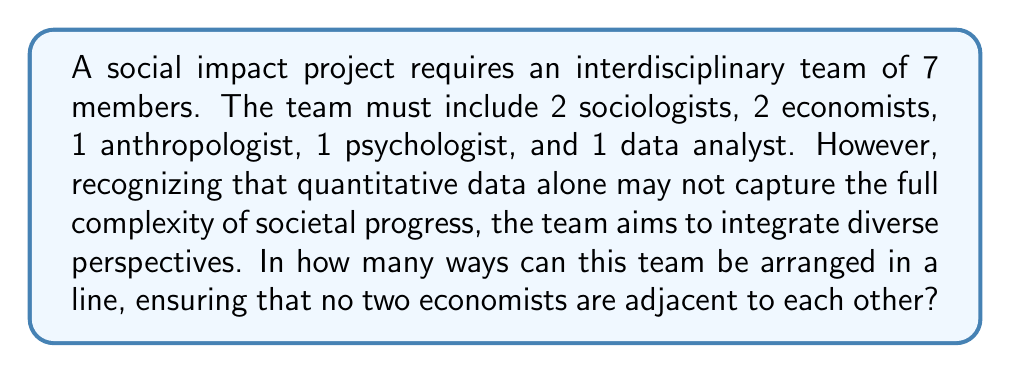Give your solution to this math problem. Let's approach this step-by-step:

1) First, consider the total number of team members: 7

2) We need to ensure that no two economists are adjacent. One way to achieve this is to first arrange all other members and then insert the economists into the gaps.

3) Let's begin by arranging the non-economist members:
   - 2 sociologists, 1 anthropologist, 1 psychologist, 1 data analyst
   This can be done in: $5! = 120$ ways

4) After arranging these 5 members, we have 6 gaps (including the ends) where we can place the economists:
   _ X _ X _ X _ X _ X _
   where X represents a non-economist member

5) We need to choose 2 out of these 6 gaps for the economists. This can be done in $\binom{6}{2} = 15$ ways

6) Once we've chosen the gaps, the 2 economists can be arranged in $2! = 2$ ways

7) By the multiplication principle, the total number of arrangements is:
   $$ 5! \times \binom{6}{2} \times 2! = 120 \times 15 \times 2 = 3600 $$

Thus, there are 3600 possible arrangements satisfying the given conditions.
Answer: 3600 